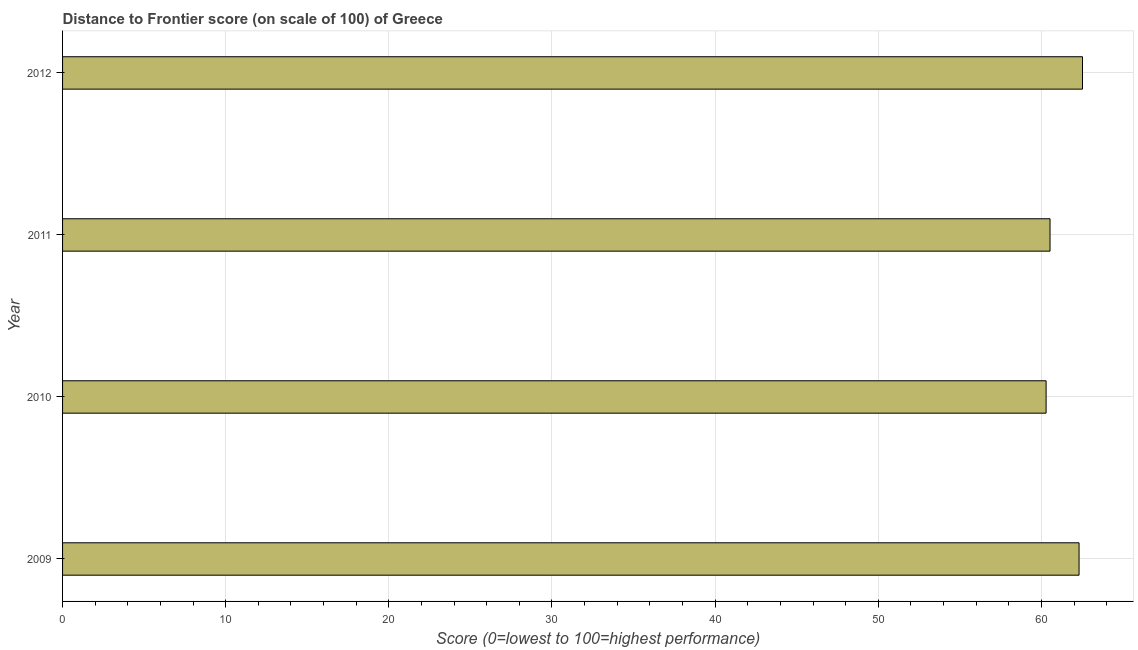Does the graph contain any zero values?
Make the answer very short. No. What is the title of the graph?
Provide a succinct answer. Distance to Frontier score (on scale of 100) of Greece. What is the label or title of the X-axis?
Keep it short and to the point. Score (0=lowest to 100=highest performance). What is the label or title of the Y-axis?
Give a very brief answer. Year. What is the distance to frontier score in 2011?
Your answer should be compact. 60.53. Across all years, what is the maximum distance to frontier score?
Your answer should be very brief. 62.52. Across all years, what is the minimum distance to frontier score?
Offer a very short reply. 60.29. In which year was the distance to frontier score minimum?
Make the answer very short. 2010. What is the sum of the distance to frontier score?
Offer a terse response. 245.65. What is the difference between the distance to frontier score in 2010 and 2012?
Provide a short and direct response. -2.23. What is the average distance to frontier score per year?
Your answer should be compact. 61.41. What is the median distance to frontier score?
Your answer should be compact. 61.42. In how many years, is the distance to frontier score greater than 62 ?
Provide a succinct answer. 2. Is the distance to frontier score in 2011 less than that in 2012?
Your answer should be very brief. Yes. What is the difference between the highest and the second highest distance to frontier score?
Give a very brief answer. 0.21. Is the sum of the distance to frontier score in 2011 and 2012 greater than the maximum distance to frontier score across all years?
Provide a short and direct response. Yes. What is the difference between the highest and the lowest distance to frontier score?
Your answer should be very brief. 2.23. Are all the bars in the graph horizontal?
Your answer should be compact. Yes. What is the difference between two consecutive major ticks on the X-axis?
Your answer should be compact. 10. Are the values on the major ticks of X-axis written in scientific E-notation?
Provide a succinct answer. No. What is the Score (0=lowest to 100=highest performance) of 2009?
Your answer should be very brief. 62.31. What is the Score (0=lowest to 100=highest performance) in 2010?
Ensure brevity in your answer.  60.29. What is the Score (0=lowest to 100=highest performance) of 2011?
Provide a succinct answer. 60.53. What is the Score (0=lowest to 100=highest performance) of 2012?
Your answer should be compact. 62.52. What is the difference between the Score (0=lowest to 100=highest performance) in 2009 and 2010?
Your answer should be very brief. 2.02. What is the difference between the Score (0=lowest to 100=highest performance) in 2009 and 2011?
Give a very brief answer. 1.78. What is the difference between the Score (0=lowest to 100=highest performance) in 2009 and 2012?
Make the answer very short. -0.21. What is the difference between the Score (0=lowest to 100=highest performance) in 2010 and 2011?
Offer a terse response. -0.24. What is the difference between the Score (0=lowest to 100=highest performance) in 2010 and 2012?
Your response must be concise. -2.23. What is the difference between the Score (0=lowest to 100=highest performance) in 2011 and 2012?
Provide a short and direct response. -1.99. What is the ratio of the Score (0=lowest to 100=highest performance) in 2009 to that in 2010?
Provide a short and direct response. 1.03. What is the ratio of the Score (0=lowest to 100=highest performance) in 2011 to that in 2012?
Your answer should be very brief. 0.97. 